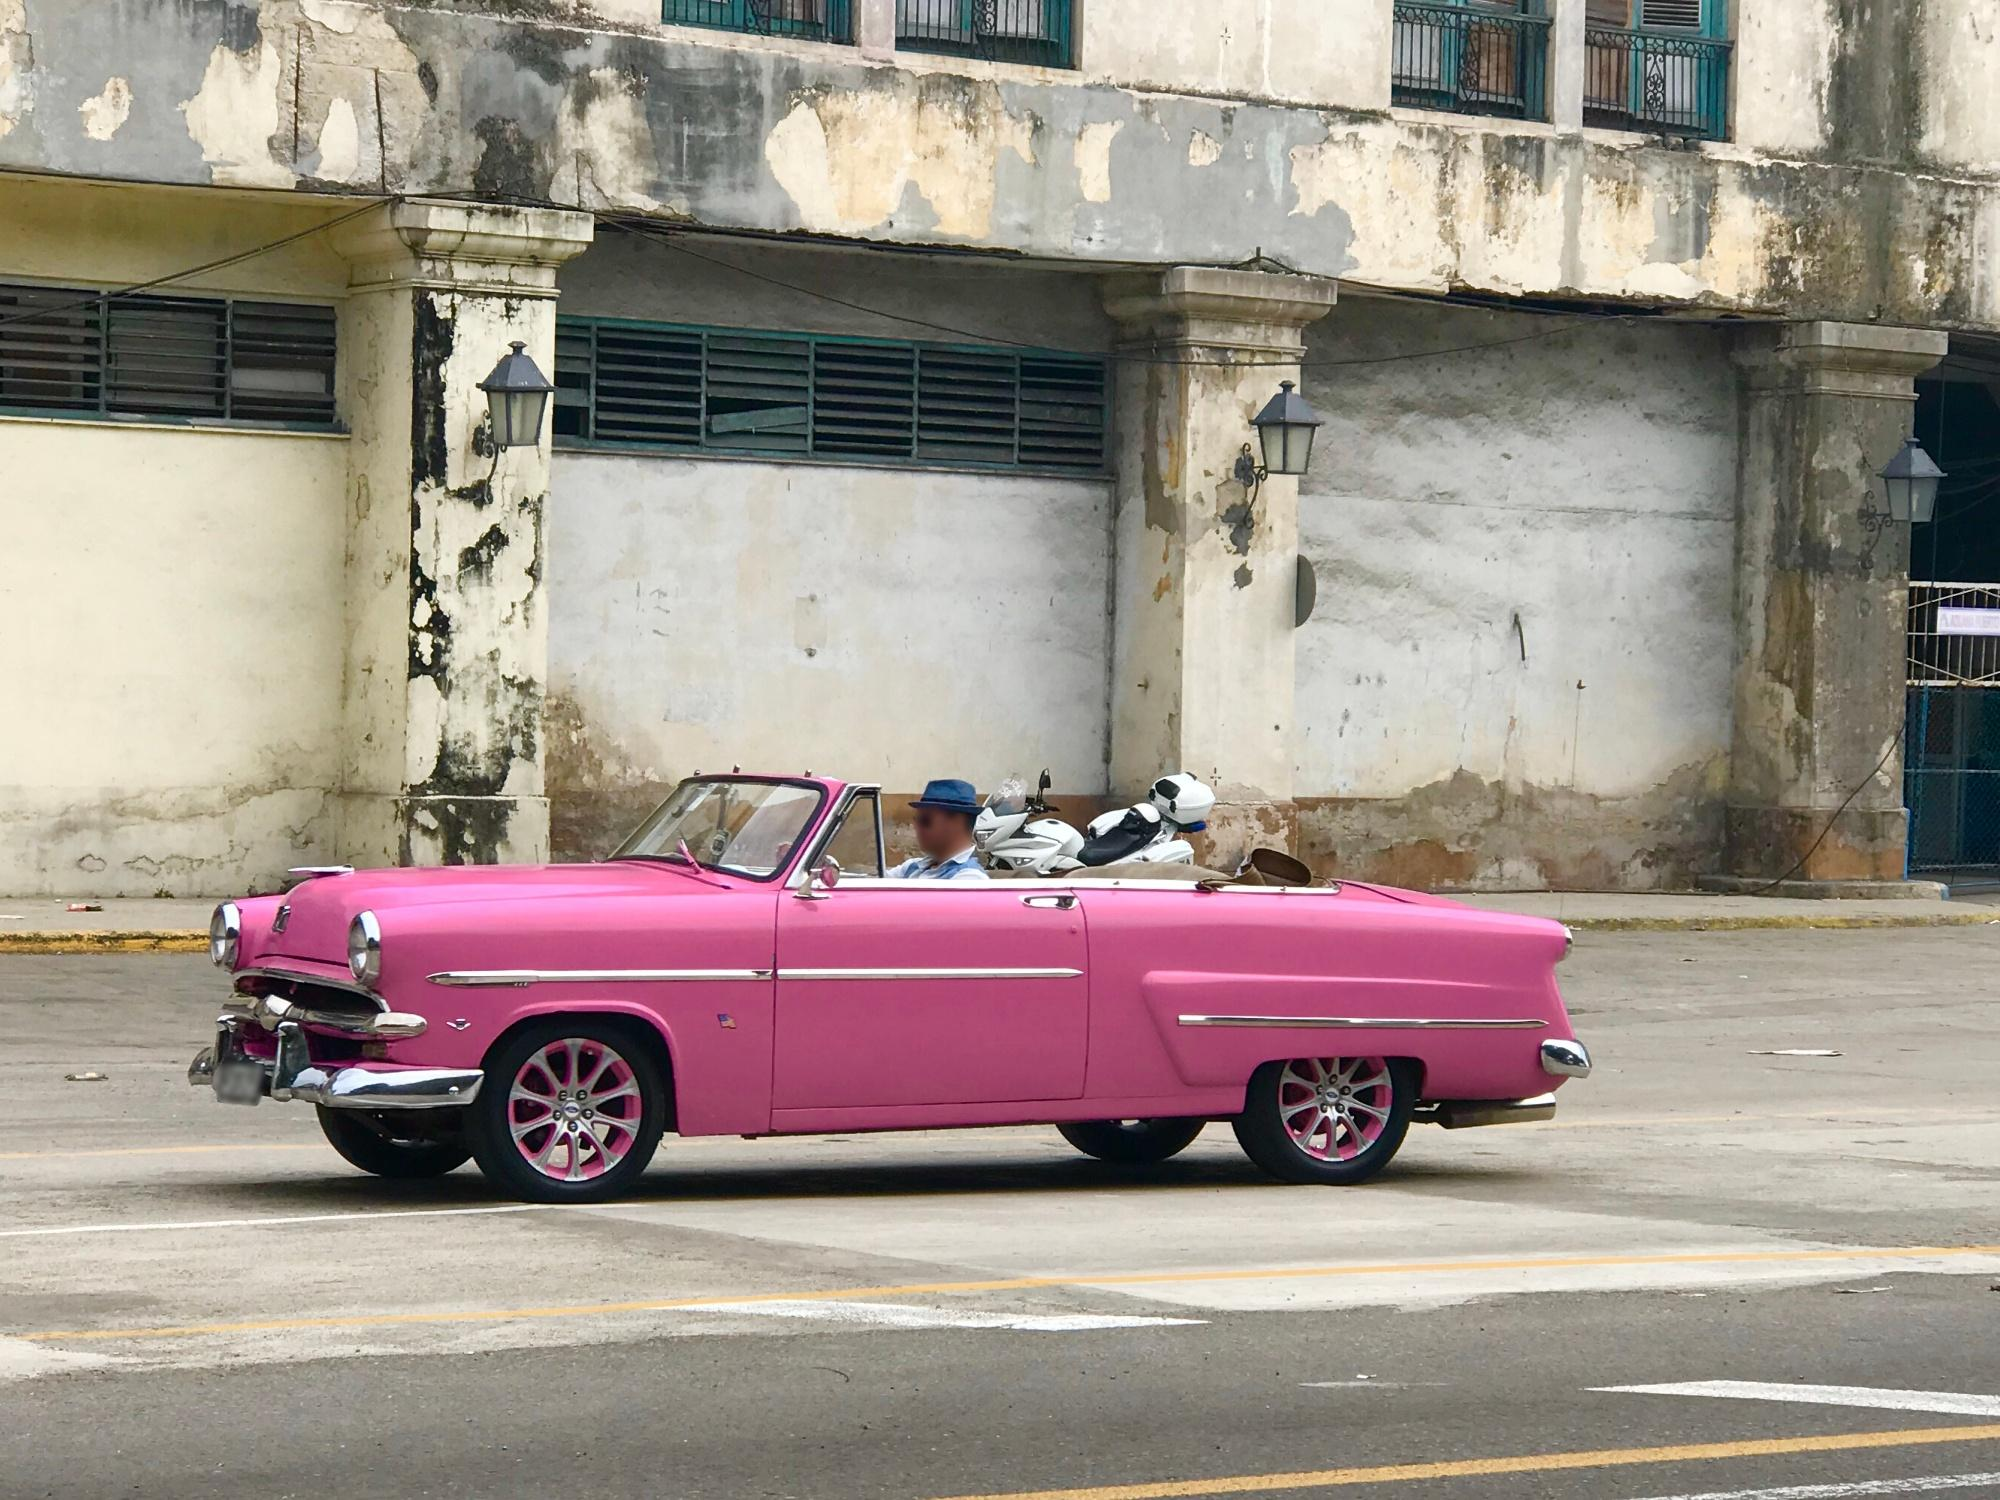Explain the visual content of the image in great detail. The image features a vibrant pink vintage convertible car with a contrasting white top, parked on a desolate urban street. The car's polished chrome bumpers, detailed pink hubcaps, and the shiny grille highlight its meticulous restoration and upkeep. Inside the car, two individuals can be seen, one behind the wheel and the other in the passenger seat, both wearing casual attire, suggesting a leisurely day out in this striking vehicle. Behind the car stands an old building, its once-white walls now peeling and yellowed with age, and windows that are boarded up, implying abandonment or disrepair. This juxtaposition of the immaculately maintained car against the backdrop of decay makes this scene not only visually striking but also hints at a narrative of beauty and neglect coexisting in the same frame. The environment and the car suggest a stark contrast between the care given to the vehicle and the neglect of the infrastructure, indicating potentially deeper socio-economic stories at play. 